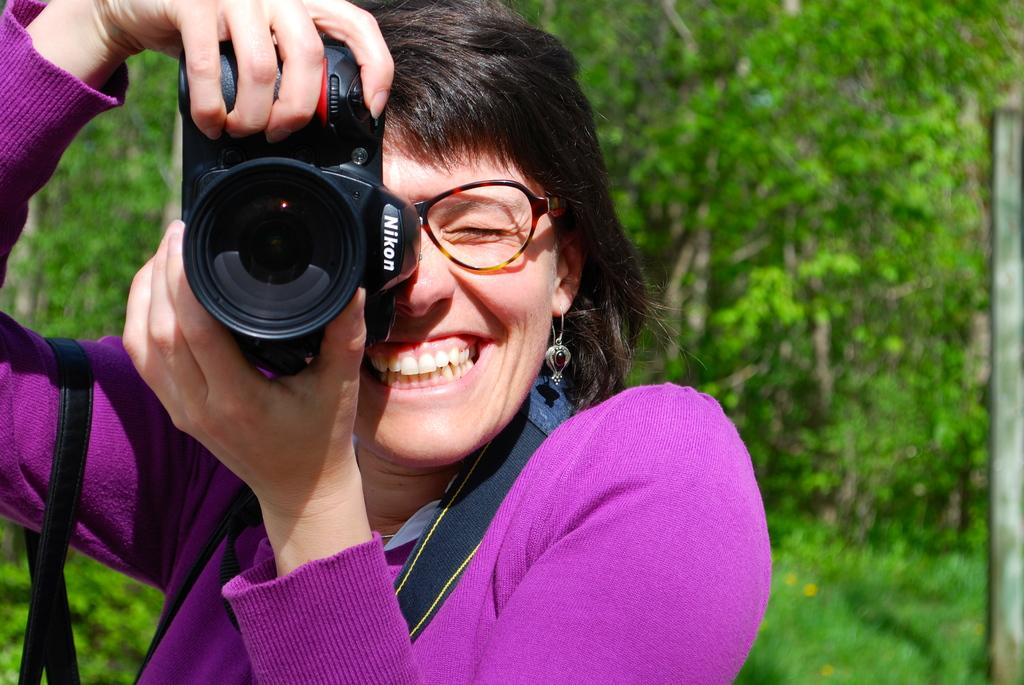Who is the main subject in the picture? There is a woman in the picture. What is the woman holding in her hands? The woman is holding a camera. What expression does the woman have on her face? The woman is smiling. What accessory is the woman wearing on her face? The woman is wearing spectacles. What can be seen in the background of the picture? There are trees in the background of the picture. What type of fly can be seen buzzing around the woman's head in the image? There is no fly present in the image. What kind of cast is the woman wearing on her leg in the image? The woman is not wearing a cast in the image; she is holding a camera and appears to be standing without any visible injuries. 